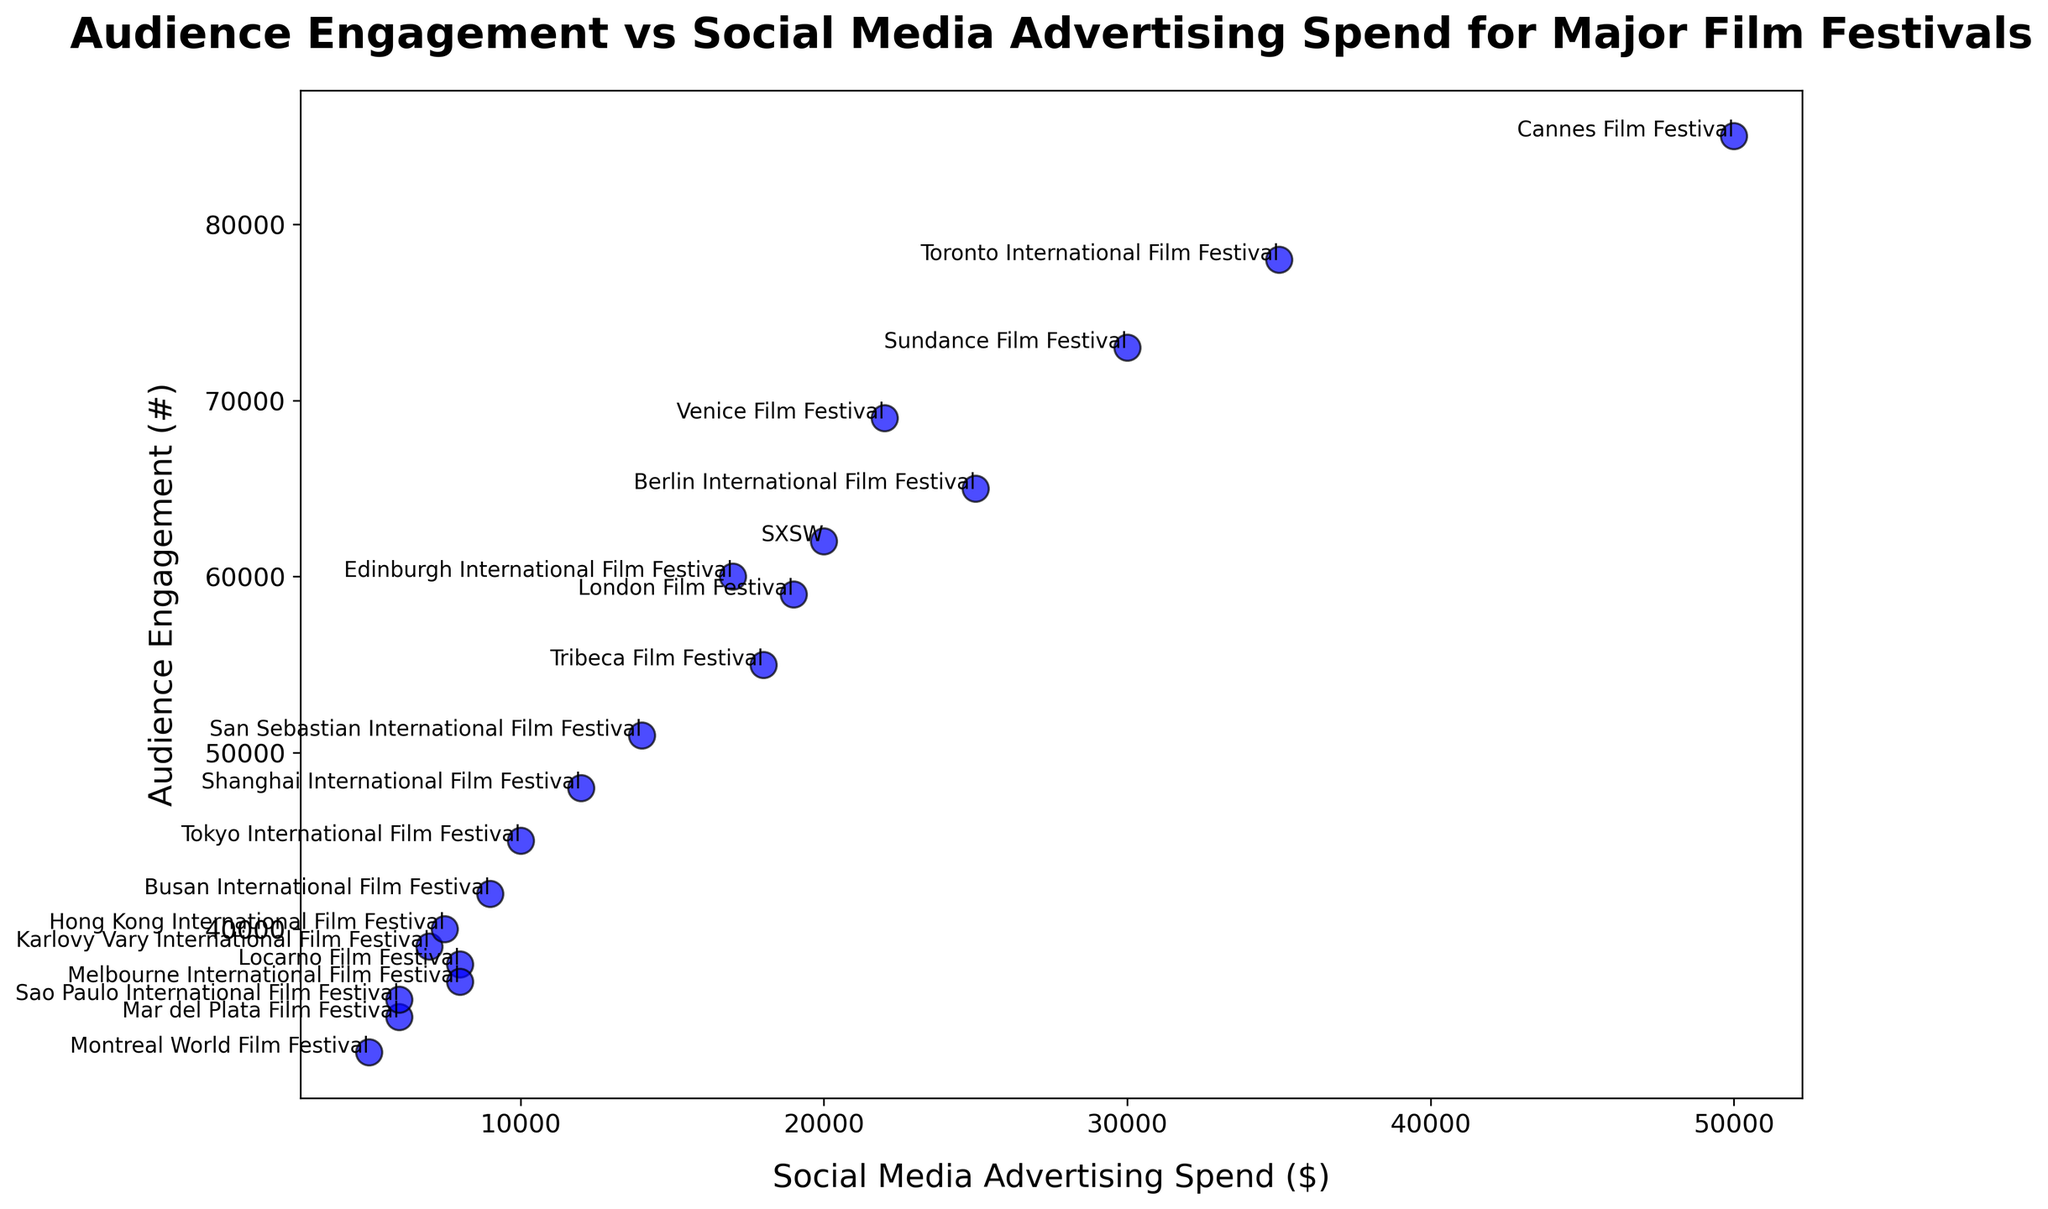Which film festival has the highest level of audience engagement? Look for the highest point on the y-axis labeled 'Audience Engagement'.
Answer: Cannes Film Festival What is the social media advertising spend for the Berlin International Film Festival? Find the point annotated with 'Berlin International Film Festival' and read the x-axis value.
Answer: $25,000 How does the audience engagement of the Toronto International Film Festival compare to that of the Venice Film Festival? Identify the points for both festivals and compare their y-axis values. Toronto is higher.
Answer: Toronto has higher engagement Which festival has the lowest social media advertising spend and what is its audience engagement? Find the point farthest to the left on the x-axis and read both the x and y values.
Answer: Montreal World Film Festival, $5,000 spend, 33,000 engagement Which two film festivals are closest in terms of social media advertising spend? Look for points that are vertically aligned or nearly so, indicating similar x-axis values.
Answer: Karlovy Vary and Hong Kong How much higher is the audience engagement for the Cannes Film Festival compared to the San Sebastian International Film Festival? Subtract the y-axis value of San Sebastian from Cannes. (85,000 - 51,000)
Answer: 34,000 What is the average social media advertising spend among the top 5 film festivals by audience engagement? Identify the top 5 film festivals by y-axis values and find the x-axis spend values, then calculate the average. ((50,000 + 30,000 + 35,000 + 22,000 + 25,000) / 5)
Answer: $32,400 Is the audience engagement of the Tokyo International Film Festival higher or lower compared to the average audience engagement of all festivals? Calculate the average engagement of all festivals, then compare it to Tokyo's engagement value (45000).
Answer: Lower What is the correlation between social media advertising spend and audience engagement? Observe the overall trend of the points. There is a positive correlation as higher spends generally correspond to higher engagement.
Answer: Positive correlation Which film festival is closest in audience engagement to the Tribeca Film Festival? Identify the point closest in y-axis value to the Tribeca Film Festival.
Answer: Edinburgh International Film Festival 